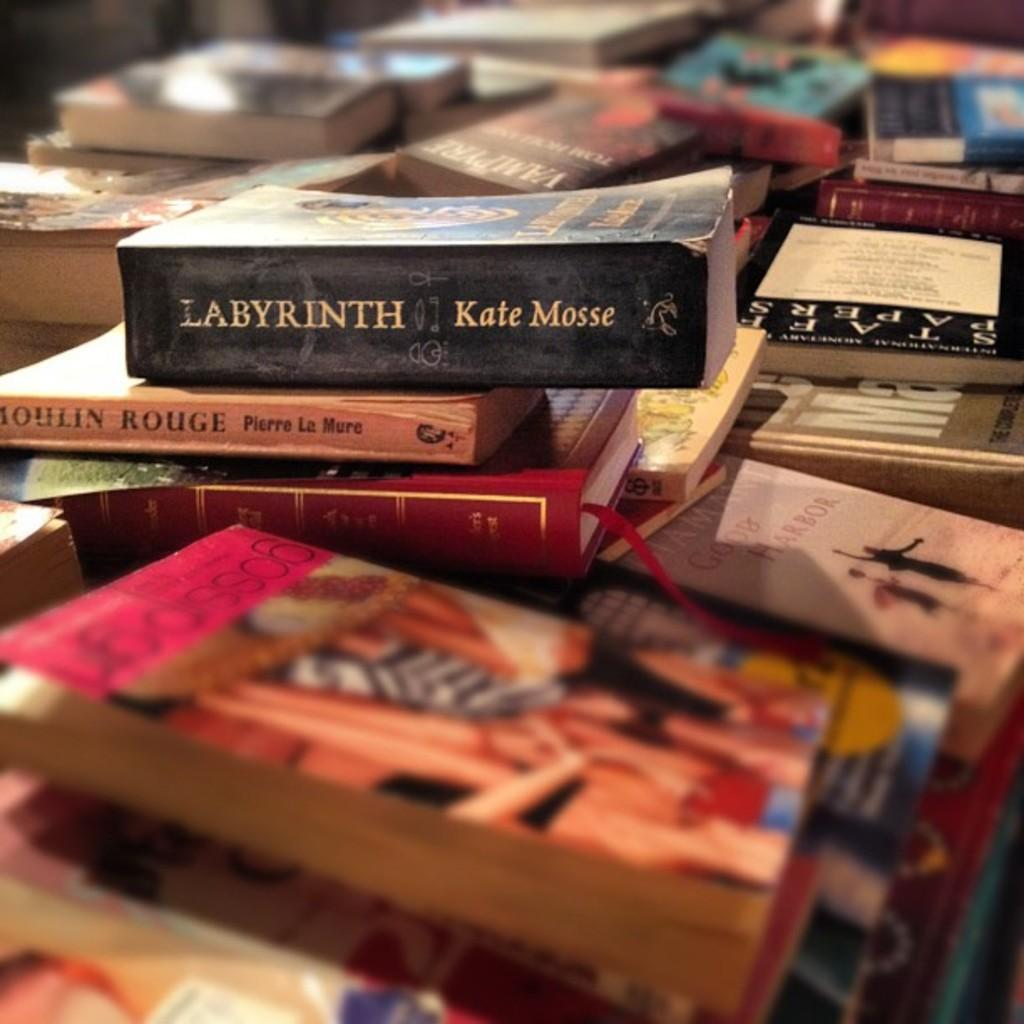<image>
Give a short and clear explanation of the subsequent image. At the top of a disorganized stack of books there is a black book written by Kate Mosse called Labyrinth. 